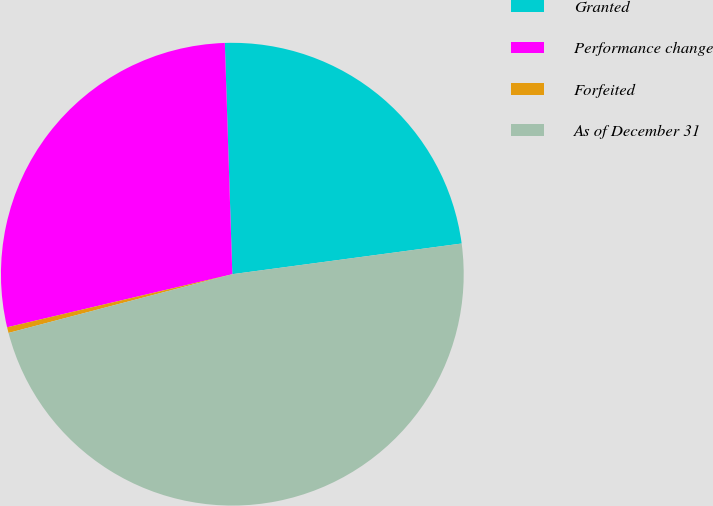Convert chart to OTSL. <chart><loc_0><loc_0><loc_500><loc_500><pie_chart><fcel>Granted<fcel>Performance change<fcel>Forfeited<fcel>As of December 31<nl><fcel>23.4%<fcel>28.17%<fcel>0.4%<fcel>48.03%<nl></chart> 